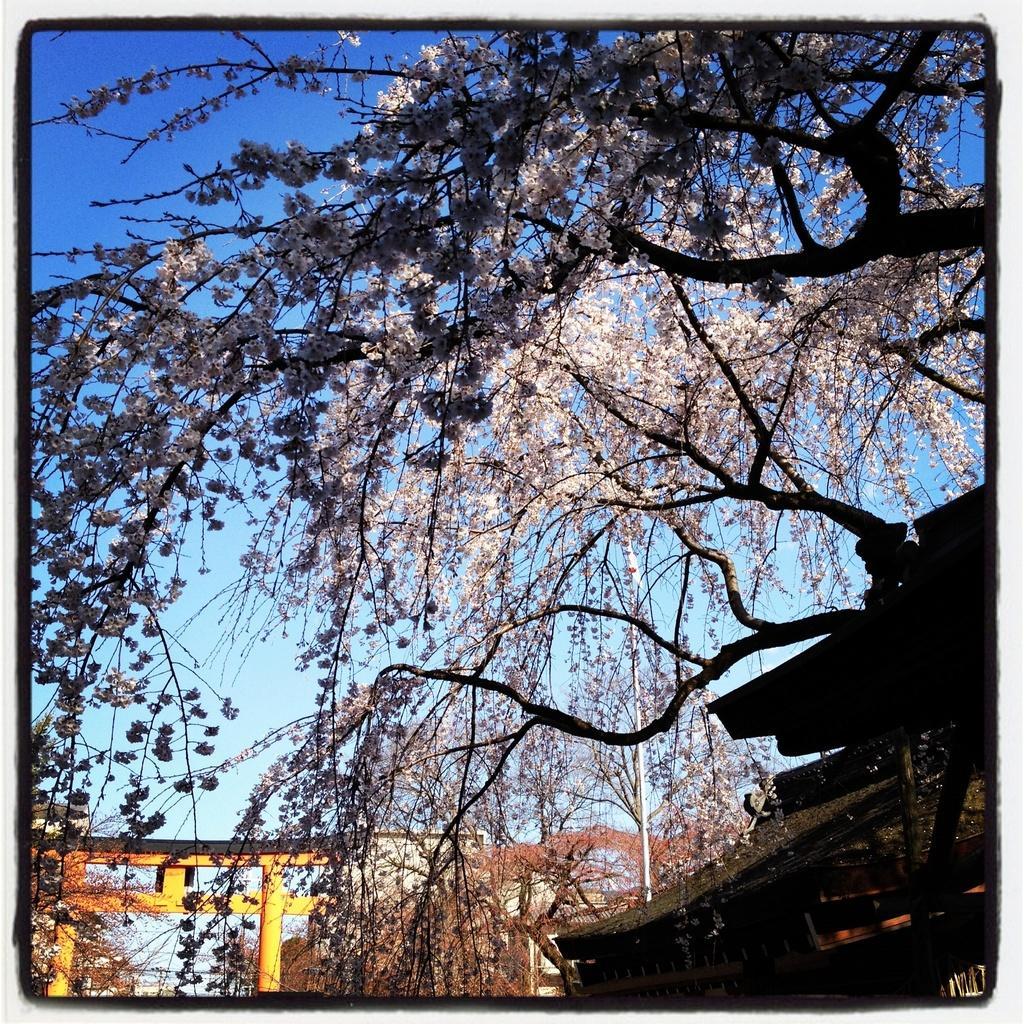Can you describe this image briefly? In this image I can see few trees. I can see a pole. I can see few buildings. In the background I can see the sky. 